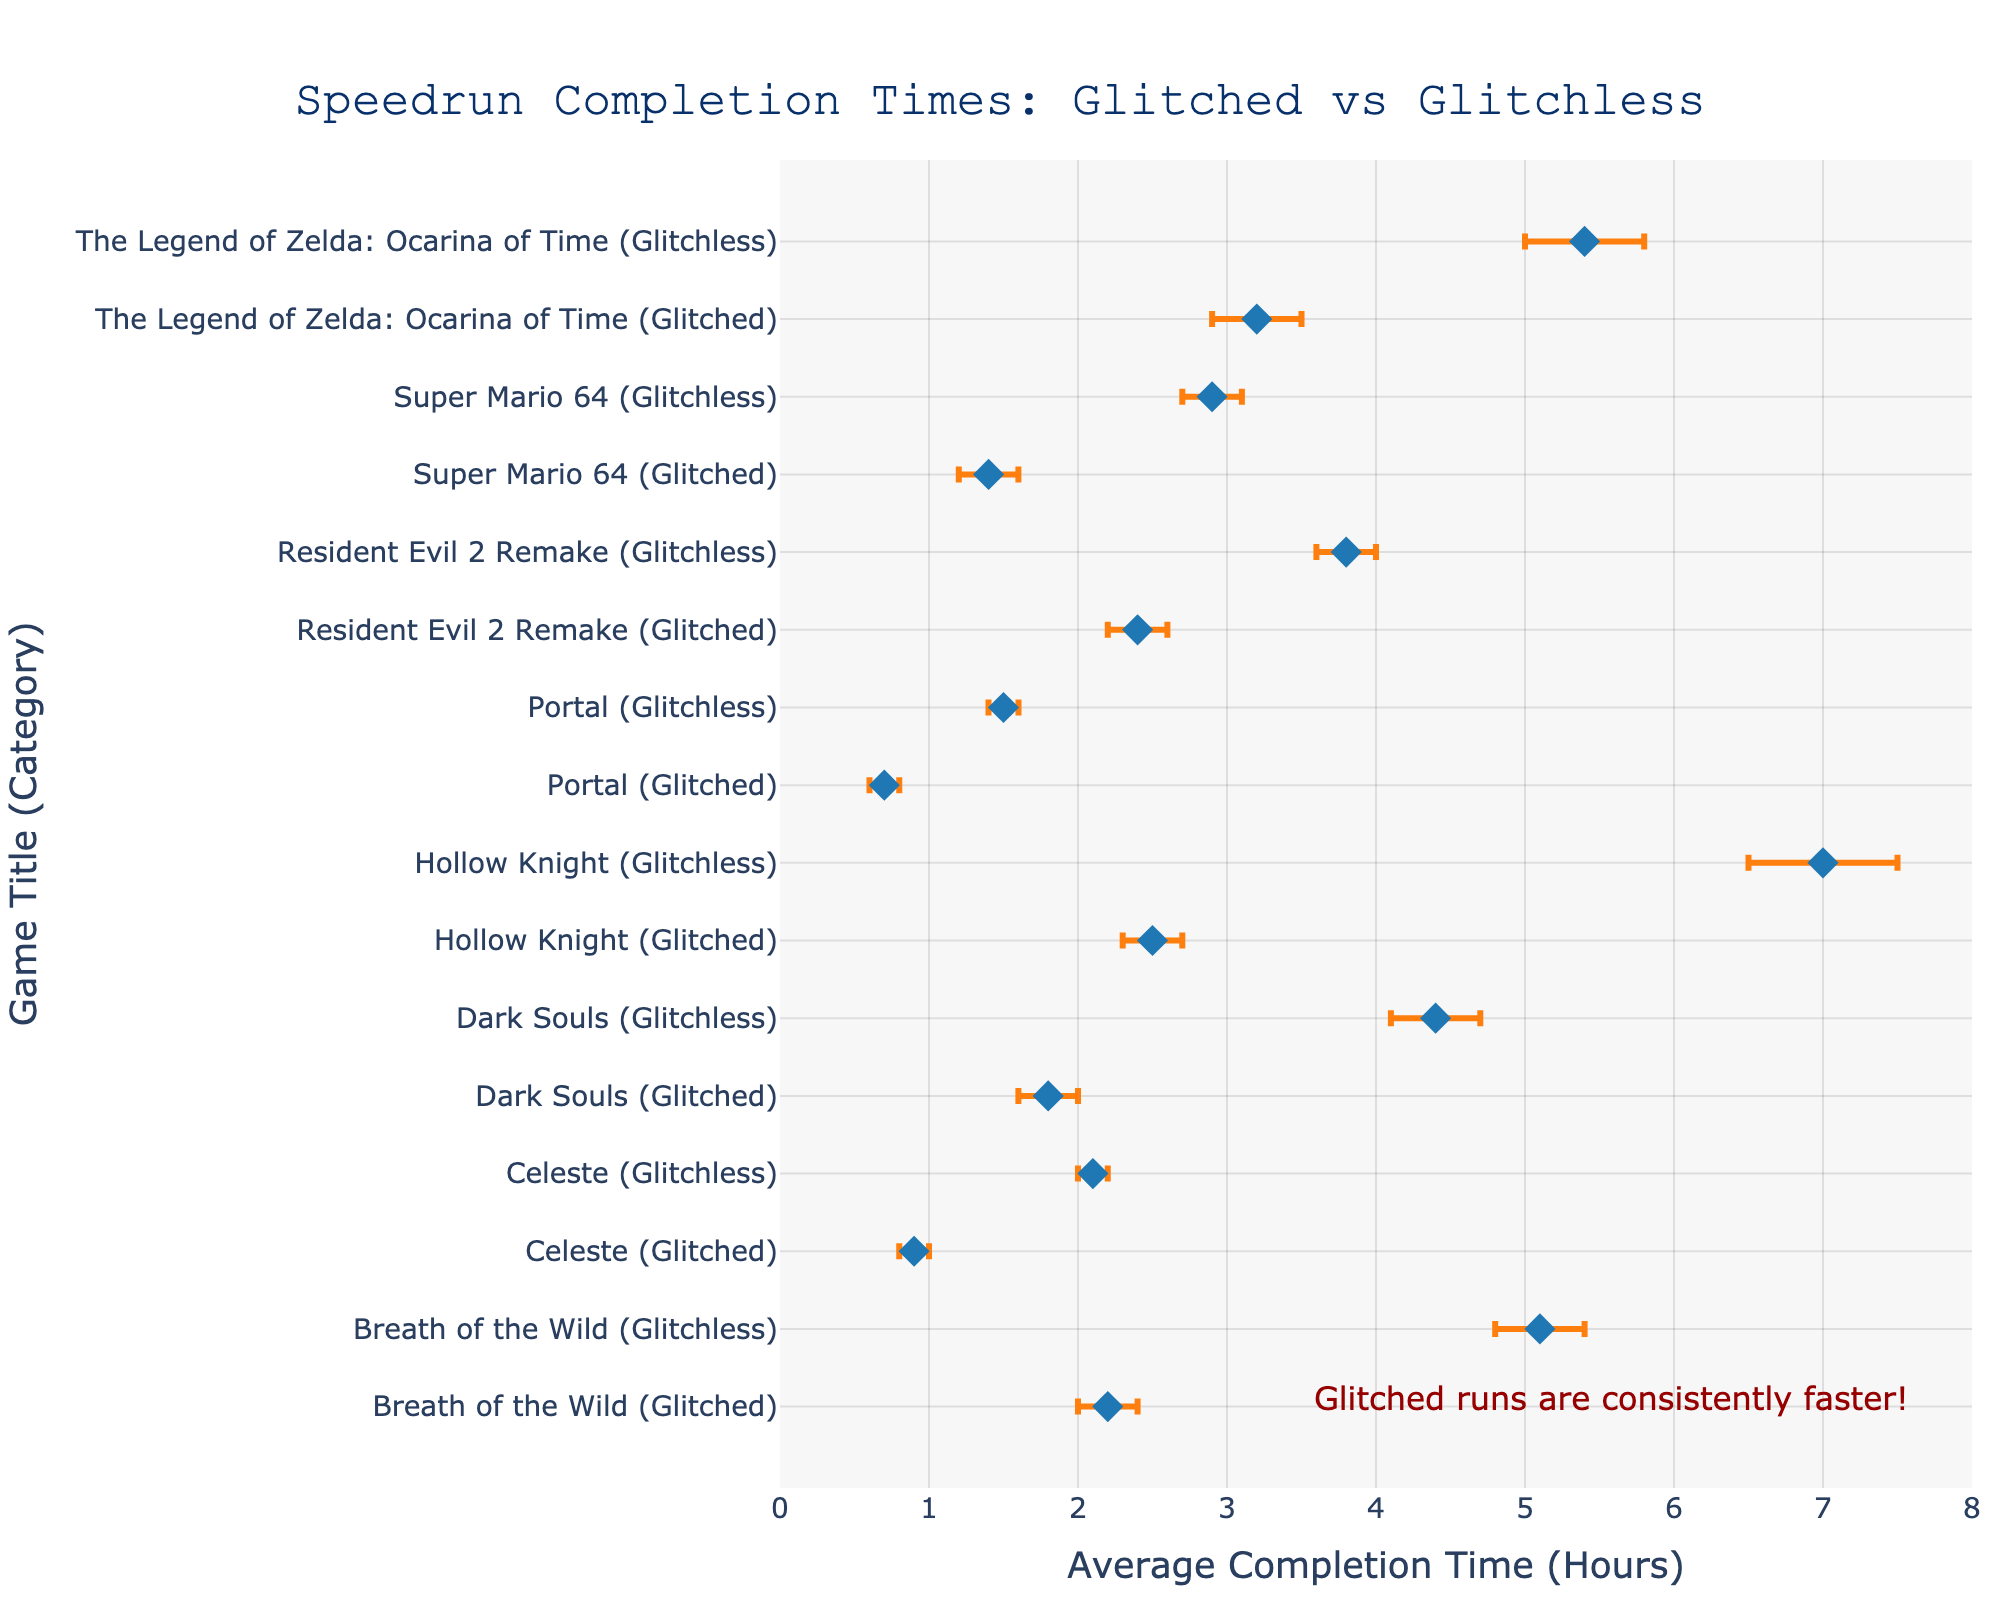What is the title of the figure? The title of the figure is displayed at the top center, reading "Speedrun Completion Times: Glitched vs Glitchless".
Answer: Speedrun Completion Times: Glitched vs Glitchless What is the average completion time for "Super Mario 64" in the glitched category? Locate "Super Mario 64 (Glitched)" on the y-axis and refer to the x-axis value corresponding to its marker. The value is 1.4 hours.
Answer: 1.4 hours Which game has the smallest average completion time in the glitched category? Identify the markers for each game in the glitched category and compare their x-axis values. The smallest value is for "Portal (Glitched)" at 0.7 hours.
Answer: Portal How much faster is the glitched run compared to the glitchless run for "The Legend of Zelda: Ocarina of Time"? Subtract the average time of the glitched run (3.2 hours) from the glitchless run (5.4 hours). The difference is 5.4 - 3.2 = 2.2 hours.
Answer: 2.2 hours What is the range of completion times for "Dark Souls" in the glitchless category? Identify the minimum and maximum times for "Dark Souls (Glitchless)"; 4.1 hours (min) and 4.7 hours (max). The range is 4.7 - 4.1 = 0.6 hours.
Answer: 0.6 hours Which game sees the largest improvement in completion time when using glitches? For each game, calculate the difference between glitchless and glitched average times and identify the maximum difference. "Hollow Knight" shows the largest improvement: 7.0 - 2.5 = 4.5 hours.
Answer: Hollow Knight What is the average of the minimum completion times for all glitchless runs? Add the minimum times for all glitchless runs and divide by the number of runs: (2.7 + 5.0 + 4.1 + 1.4 + 3.6 + 2.0 + 6.5 + 4.8) / 8 = 29.1 / 8 = 3.6375 hours.
Answer: 3.64 hours Which category shows a more consistent completion time range for "Celeste"? Compare the error bars (range) for "Celeste (Glitched)" and "Celeste (Glitchless)"; Glitched has a range of 1.0 - 0.8 = 0.2 hours, and Glitchless has 2.2 - 2.0 = 0.2 hours. Both show equal consistency.
Answer: Both categories are equal For how many games is the average glitched completion time less than half of the average glitchless completion time? Compare each game's glitched time to half its glitchless time: Only "Dark Souls (1.8 < 4.4/2 = 2.2)", and "Breath of the Wild (2.2 < 5.1/2 = 2.55)" satisfy this condition.
Answer: 2 games What is the median average completion time for all glitchless runs? Ordering the glitchless times: (1.5, 2.1, 2.9, 3.8, 4.4, 5.1, 5.4, 7.0). There are 8 values, the median is the average of the 4th and 5th values: (3.8 + 4.4) / 2 = 4.1 hours.
Answer: 4.1 hours 